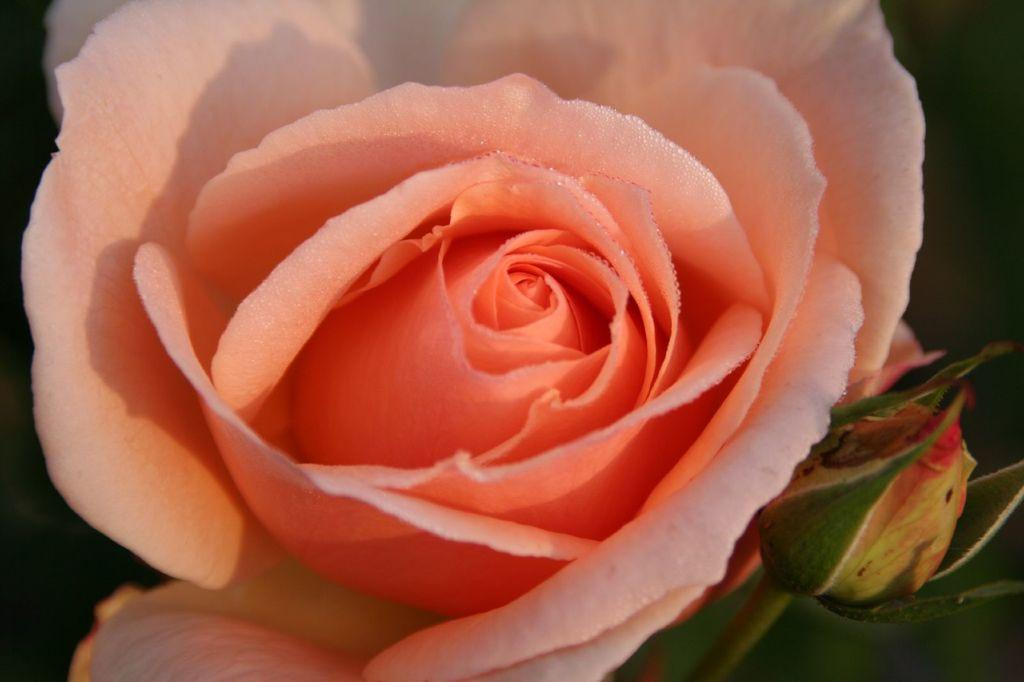What type of flower is in the image? There is a rose flower in the image. What color are the petals of the rose flower? The rose flower has pink petals. What type of gold object is hanging from the rose flower in the image? There is no gold object present in the image, and the rose flower is not hanging from anything. Can you see any icicles or camera equipment in the image? There are no icicles or camera equipment present in the image; it only features a rose flower with pink petals. 